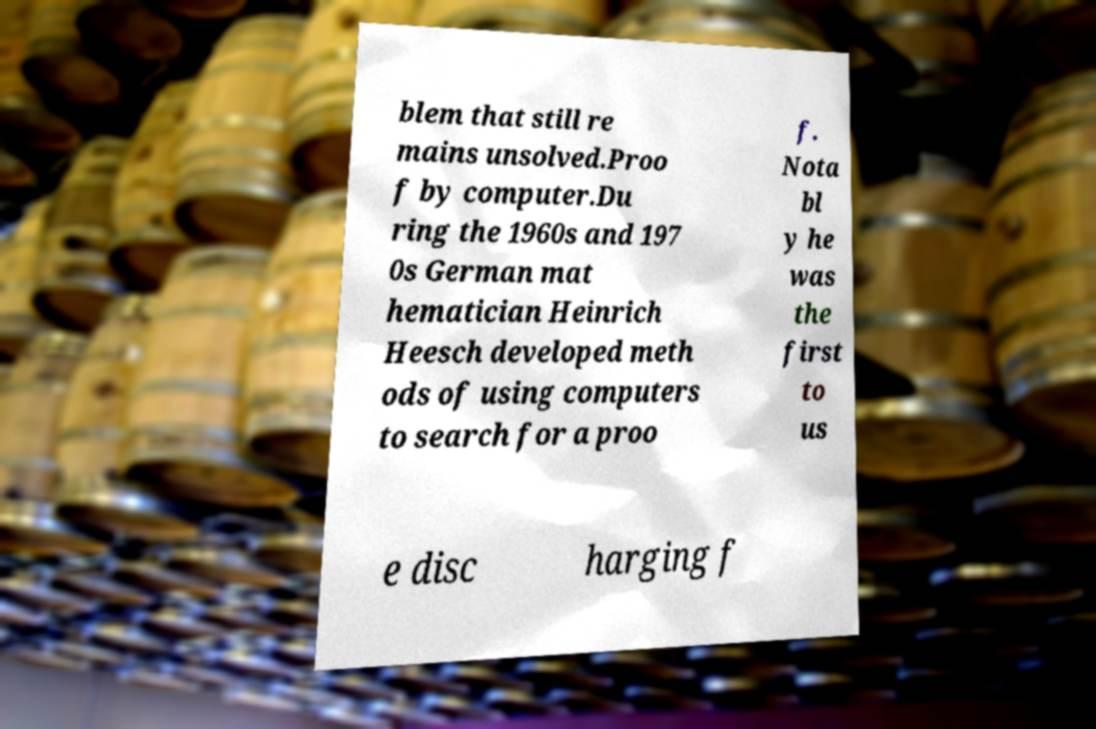I need the written content from this picture converted into text. Can you do that? blem that still re mains unsolved.Proo f by computer.Du ring the 1960s and 197 0s German mat hematician Heinrich Heesch developed meth ods of using computers to search for a proo f. Nota bl y he was the first to us e disc harging f 